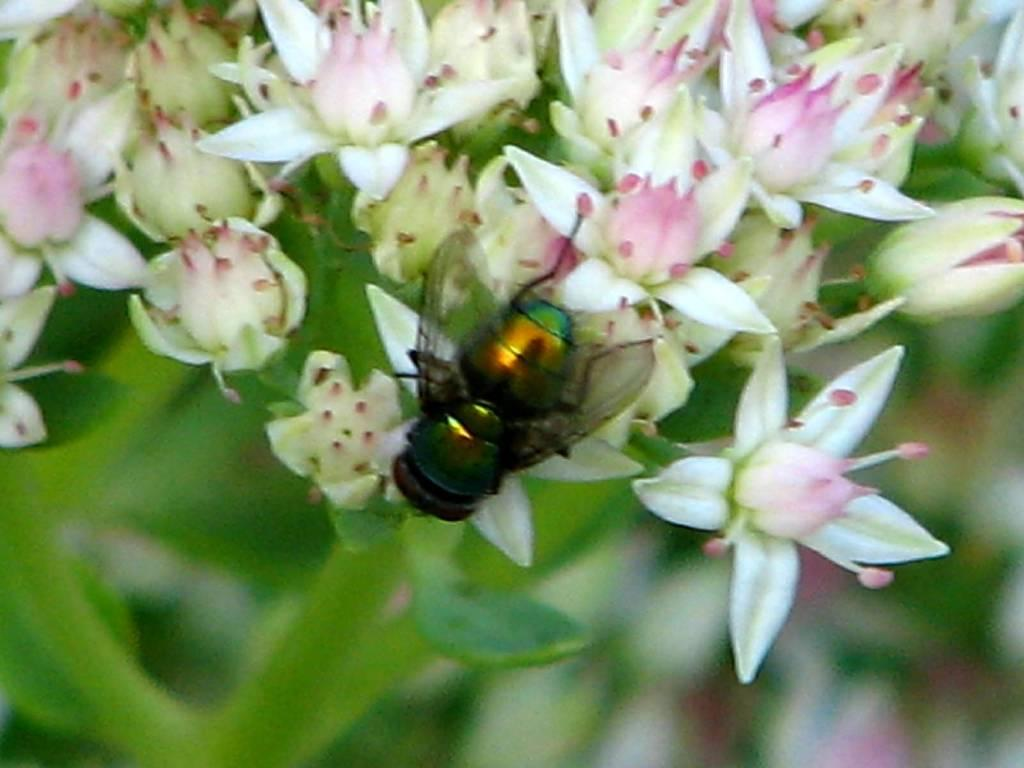What is on the flower in the image? There is an insect on a flower in the image. What else can be seen in the image besides the insect? There is a bunch of flowers on a plant in the image. What type of substance is the fireman using to put out the fire on the pig in the image? There is no fireman, fire, or pig present in the image; it features an insect on a flower and a bunch of flowers on a plant. 